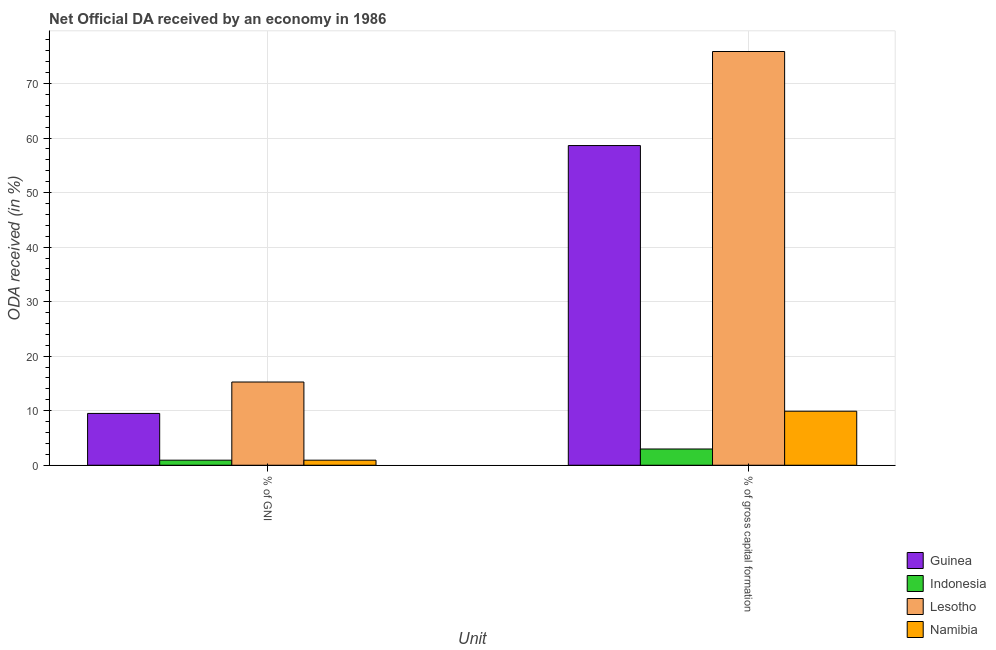How many groups of bars are there?
Your answer should be compact. 2. Are the number of bars per tick equal to the number of legend labels?
Provide a short and direct response. Yes. Are the number of bars on each tick of the X-axis equal?
Your answer should be compact. Yes. How many bars are there on the 1st tick from the right?
Provide a short and direct response. 4. What is the label of the 2nd group of bars from the left?
Provide a succinct answer. % of gross capital formation. What is the oda received as percentage of gross capital formation in Guinea?
Your response must be concise. 58.62. Across all countries, what is the maximum oda received as percentage of gross capital formation?
Make the answer very short. 75.87. Across all countries, what is the minimum oda received as percentage of gni?
Offer a very short reply. 0.93. In which country was the oda received as percentage of gni maximum?
Keep it short and to the point. Lesotho. What is the total oda received as percentage of gni in the graph?
Make the answer very short. 26.62. What is the difference between the oda received as percentage of gni in Guinea and that in Indonesia?
Make the answer very short. 8.58. What is the difference between the oda received as percentage of gni in Guinea and the oda received as percentage of gross capital formation in Namibia?
Offer a terse response. -0.4. What is the average oda received as percentage of gross capital formation per country?
Provide a short and direct response. 36.84. What is the difference between the oda received as percentage of gni and oda received as percentage of gross capital formation in Indonesia?
Offer a terse response. -2.05. In how many countries, is the oda received as percentage of gross capital formation greater than 50 %?
Ensure brevity in your answer.  2. What is the ratio of the oda received as percentage of gni in Lesotho to that in Namibia?
Offer a terse response. 16.44. Is the oda received as percentage of gni in Guinea less than that in Lesotho?
Your answer should be compact. Yes. In how many countries, is the oda received as percentage of gross capital formation greater than the average oda received as percentage of gross capital formation taken over all countries?
Your response must be concise. 2. What does the 1st bar from the left in % of gross capital formation represents?
Make the answer very short. Guinea. What does the 1st bar from the right in % of GNI represents?
Your response must be concise. Namibia. Are all the bars in the graph horizontal?
Offer a terse response. No. Are the values on the major ticks of Y-axis written in scientific E-notation?
Your response must be concise. No. Does the graph contain any zero values?
Your answer should be compact. No. Does the graph contain grids?
Offer a very short reply. Yes. How are the legend labels stacked?
Offer a terse response. Vertical. What is the title of the graph?
Offer a very short reply. Net Official DA received by an economy in 1986. Does "High income: nonOECD" appear as one of the legend labels in the graph?
Your response must be concise. No. What is the label or title of the X-axis?
Make the answer very short. Unit. What is the label or title of the Y-axis?
Provide a succinct answer. ODA received (in %). What is the ODA received (in %) of Guinea in % of GNI?
Provide a succinct answer. 9.5. What is the ODA received (in %) of Indonesia in % of GNI?
Offer a terse response. 0.93. What is the ODA received (in %) in Lesotho in % of GNI?
Keep it short and to the point. 15.26. What is the ODA received (in %) of Namibia in % of GNI?
Your response must be concise. 0.93. What is the ODA received (in %) of Guinea in % of gross capital formation?
Keep it short and to the point. 58.62. What is the ODA received (in %) in Indonesia in % of gross capital formation?
Make the answer very short. 2.98. What is the ODA received (in %) in Lesotho in % of gross capital formation?
Make the answer very short. 75.87. What is the ODA received (in %) of Namibia in % of gross capital formation?
Give a very brief answer. 9.91. Across all Unit, what is the maximum ODA received (in %) in Guinea?
Ensure brevity in your answer.  58.62. Across all Unit, what is the maximum ODA received (in %) in Indonesia?
Provide a succinct answer. 2.98. Across all Unit, what is the maximum ODA received (in %) in Lesotho?
Ensure brevity in your answer.  75.87. Across all Unit, what is the maximum ODA received (in %) in Namibia?
Your answer should be very brief. 9.91. Across all Unit, what is the minimum ODA received (in %) in Guinea?
Provide a short and direct response. 9.5. Across all Unit, what is the minimum ODA received (in %) in Indonesia?
Keep it short and to the point. 0.93. Across all Unit, what is the minimum ODA received (in %) in Lesotho?
Keep it short and to the point. 15.26. Across all Unit, what is the minimum ODA received (in %) of Namibia?
Give a very brief answer. 0.93. What is the total ODA received (in %) in Guinea in the graph?
Your answer should be compact. 68.12. What is the total ODA received (in %) of Indonesia in the graph?
Your answer should be very brief. 3.91. What is the total ODA received (in %) in Lesotho in the graph?
Keep it short and to the point. 91.13. What is the total ODA received (in %) of Namibia in the graph?
Provide a succinct answer. 10.83. What is the difference between the ODA received (in %) in Guinea in % of GNI and that in % of gross capital formation?
Your response must be concise. -49.12. What is the difference between the ODA received (in %) in Indonesia in % of GNI and that in % of gross capital formation?
Your response must be concise. -2.05. What is the difference between the ODA received (in %) in Lesotho in % of GNI and that in % of gross capital formation?
Provide a short and direct response. -60.6. What is the difference between the ODA received (in %) in Namibia in % of GNI and that in % of gross capital formation?
Provide a succinct answer. -8.98. What is the difference between the ODA received (in %) in Guinea in % of GNI and the ODA received (in %) in Indonesia in % of gross capital formation?
Offer a terse response. 6.52. What is the difference between the ODA received (in %) in Guinea in % of GNI and the ODA received (in %) in Lesotho in % of gross capital formation?
Keep it short and to the point. -66.36. What is the difference between the ODA received (in %) in Guinea in % of GNI and the ODA received (in %) in Namibia in % of gross capital formation?
Offer a very short reply. -0.4. What is the difference between the ODA received (in %) in Indonesia in % of GNI and the ODA received (in %) in Lesotho in % of gross capital formation?
Your answer should be compact. -74.94. What is the difference between the ODA received (in %) of Indonesia in % of GNI and the ODA received (in %) of Namibia in % of gross capital formation?
Offer a terse response. -8.98. What is the difference between the ODA received (in %) in Lesotho in % of GNI and the ODA received (in %) in Namibia in % of gross capital formation?
Offer a terse response. 5.36. What is the average ODA received (in %) in Guinea per Unit?
Keep it short and to the point. 34.06. What is the average ODA received (in %) in Indonesia per Unit?
Your response must be concise. 1.95. What is the average ODA received (in %) of Lesotho per Unit?
Offer a terse response. 45.56. What is the average ODA received (in %) of Namibia per Unit?
Offer a very short reply. 5.42. What is the difference between the ODA received (in %) of Guinea and ODA received (in %) of Indonesia in % of GNI?
Your answer should be compact. 8.57. What is the difference between the ODA received (in %) in Guinea and ODA received (in %) in Lesotho in % of GNI?
Ensure brevity in your answer.  -5.76. What is the difference between the ODA received (in %) in Guinea and ODA received (in %) in Namibia in % of GNI?
Provide a succinct answer. 8.57. What is the difference between the ODA received (in %) in Indonesia and ODA received (in %) in Lesotho in % of GNI?
Your response must be concise. -14.34. What is the difference between the ODA received (in %) in Indonesia and ODA received (in %) in Namibia in % of GNI?
Ensure brevity in your answer.  -0. What is the difference between the ODA received (in %) of Lesotho and ODA received (in %) of Namibia in % of GNI?
Give a very brief answer. 14.33. What is the difference between the ODA received (in %) in Guinea and ODA received (in %) in Indonesia in % of gross capital formation?
Your answer should be very brief. 55.64. What is the difference between the ODA received (in %) in Guinea and ODA received (in %) in Lesotho in % of gross capital formation?
Give a very brief answer. -17.24. What is the difference between the ODA received (in %) of Guinea and ODA received (in %) of Namibia in % of gross capital formation?
Ensure brevity in your answer.  48.72. What is the difference between the ODA received (in %) of Indonesia and ODA received (in %) of Lesotho in % of gross capital formation?
Your response must be concise. -72.89. What is the difference between the ODA received (in %) in Indonesia and ODA received (in %) in Namibia in % of gross capital formation?
Offer a terse response. -6.93. What is the difference between the ODA received (in %) of Lesotho and ODA received (in %) of Namibia in % of gross capital formation?
Make the answer very short. 65.96. What is the ratio of the ODA received (in %) of Guinea in % of GNI to that in % of gross capital formation?
Provide a short and direct response. 0.16. What is the ratio of the ODA received (in %) of Indonesia in % of GNI to that in % of gross capital formation?
Offer a very short reply. 0.31. What is the ratio of the ODA received (in %) of Lesotho in % of GNI to that in % of gross capital formation?
Your answer should be very brief. 0.2. What is the ratio of the ODA received (in %) in Namibia in % of GNI to that in % of gross capital formation?
Keep it short and to the point. 0.09. What is the difference between the highest and the second highest ODA received (in %) in Guinea?
Your response must be concise. 49.12. What is the difference between the highest and the second highest ODA received (in %) of Indonesia?
Make the answer very short. 2.05. What is the difference between the highest and the second highest ODA received (in %) in Lesotho?
Ensure brevity in your answer.  60.6. What is the difference between the highest and the second highest ODA received (in %) of Namibia?
Ensure brevity in your answer.  8.98. What is the difference between the highest and the lowest ODA received (in %) in Guinea?
Make the answer very short. 49.12. What is the difference between the highest and the lowest ODA received (in %) in Indonesia?
Give a very brief answer. 2.05. What is the difference between the highest and the lowest ODA received (in %) of Lesotho?
Keep it short and to the point. 60.6. What is the difference between the highest and the lowest ODA received (in %) of Namibia?
Keep it short and to the point. 8.98. 